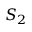<formula> <loc_0><loc_0><loc_500><loc_500>S _ { 2 }</formula> 